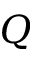<formula> <loc_0><loc_0><loc_500><loc_500>Q</formula> 